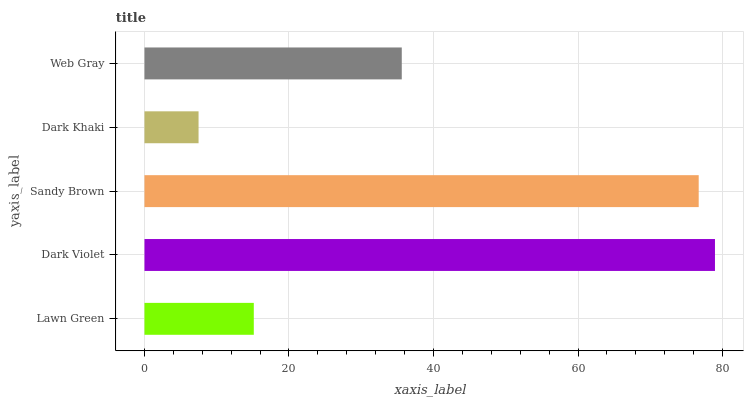Is Dark Khaki the minimum?
Answer yes or no. Yes. Is Dark Violet the maximum?
Answer yes or no. Yes. Is Sandy Brown the minimum?
Answer yes or no. No. Is Sandy Brown the maximum?
Answer yes or no. No. Is Dark Violet greater than Sandy Brown?
Answer yes or no. Yes. Is Sandy Brown less than Dark Violet?
Answer yes or no. Yes. Is Sandy Brown greater than Dark Violet?
Answer yes or no. No. Is Dark Violet less than Sandy Brown?
Answer yes or no. No. Is Web Gray the high median?
Answer yes or no. Yes. Is Web Gray the low median?
Answer yes or no. Yes. Is Lawn Green the high median?
Answer yes or no. No. Is Dark Violet the low median?
Answer yes or no. No. 